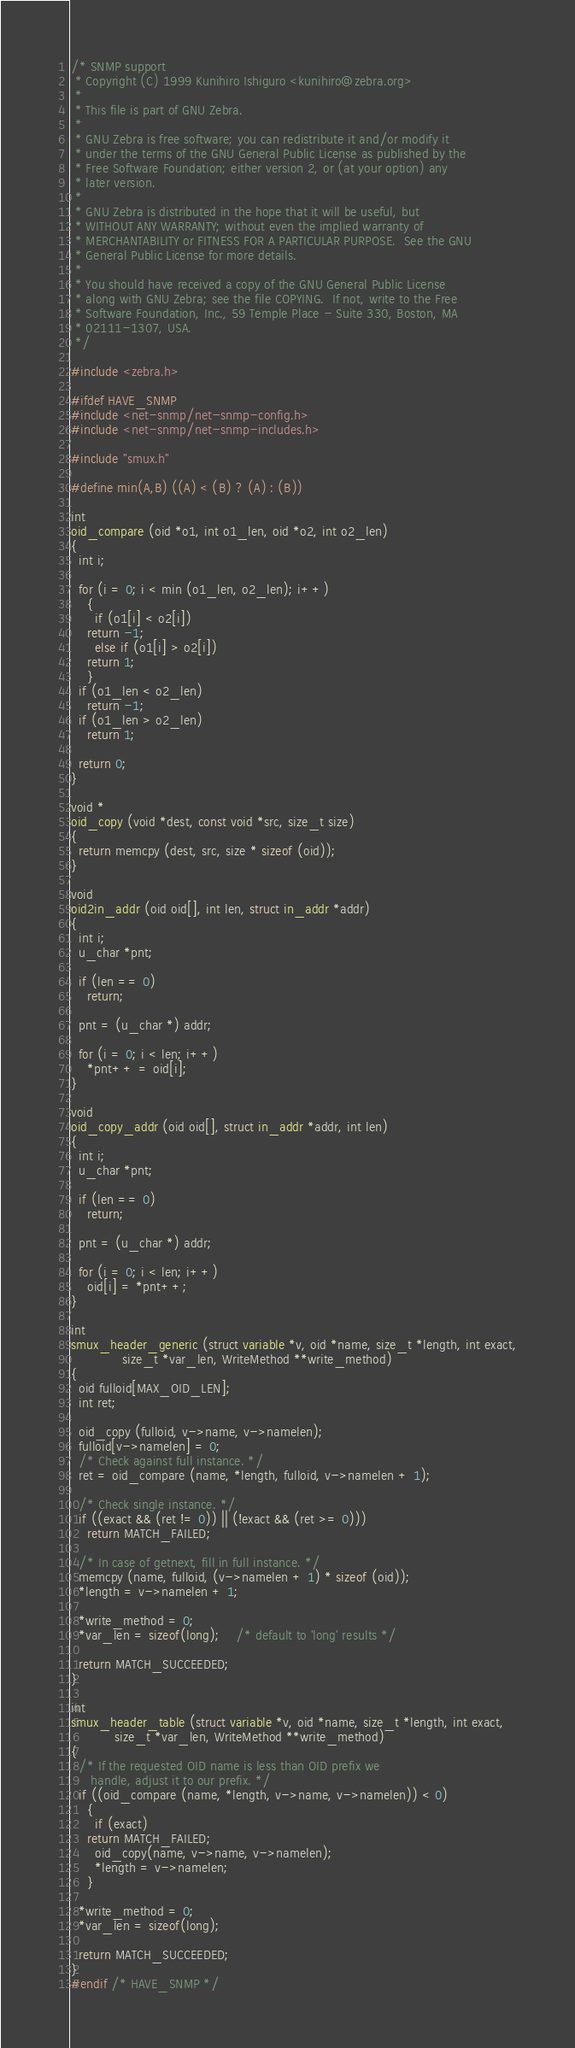<code> <loc_0><loc_0><loc_500><loc_500><_C_>/* SNMP support
 * Copyright (C) 1999 Kunihiro Ishiguro <kunihiro@zebra.org>
 *
 * This file is part of GNU Zebra.
 *
 * GNU Zebra is free software; you can redistribute it and/or modify it
 * under the terms of the GNU General Public License as published by the
 * Free Software Foundation; either version 2, or (at your option) any
 * later version.
 *
 * GNU Zebra is distributed in the hope that it will be useful, but
 * WITHOUT ANY WARRANTY; without even the implied warranty of
 * MERCHANTABILITY or FITNESS FOR A PARTICULAR PURPOSE.  See the GNU
 * General Public License for more details.
 *
 * You should have received a copy of the GNU General Public License
 * along with GNU Zebra; see the file COPYING.  If not, write to the Free
 * Software Foundation, Inc., 59 Temple Place - Suite 330, Boston, MA
 * 02111-1307, USA.  
 */

#include <zebra.h>

#ifdef HAVE_SNMP
#include <net-snmp/net-snmp-config.h>
#include <net-snmp/net-snmp-includes.h>

#include "smux.h"

#define min(A,B) ((A) < (B) ? (A) : (B))

int
oid_compare (oid *o1, int o1_len, oid *o2, int o2_len)
{
  int i;

  for (i = 0; i < min (o1_len, o2_len); i++)
    {
      if (o1[i] < o2[i])
	return -1;
      else if (o1[i] > o2[i])
	return 1;
    }
  if (o1_len < o2_len)
    return -1;
  if (o1_len > o2_len)
    return 1;

  return 0;
}

void *
oid_copy (void *dest, const void *src, size_t size)
{
  return memcpy (dest, src, size * sizeof (oid));
}

void
oid2in_addr (oid oid[], int len, struct in_addr *addr)
{
  int i;
  u_char *pnt;
  
  if (len == 0)
    return;

  pnt = (u_char *) addr;

  for (i = 0; i < len; i++)
    *pnt++ = oid[i];
}

void
oid_copy_addr (oid oid[], struct in_addr *addr, int len)
{
  int i;
  u_char *pnt;
  
  if (len == 0)
    return;

  pnt = (u_char *) addr;

  for (i = 0; i < len; i++)
    oid[i] = *pnt++;
}

int
smux_header_generic (struct variable *v, oid *name, size_t *length, int exact,
		     size_t *var_len, WriteMethod **write_method)
{
  oid fulloid[MAX_OID_LEN];
  int ret;

  oid_copy (fulloid, v->name, v->namelen);
  fulloid[v->namelen] = 0;
  /* Check against full instance. */
  ret = oid_compare (name, *length, fulloid, v->namelen + 1);

  /* Check single instance. */
  if ((exact && (ret != 0)) || (!exact && (ret >= 0)))
	return MATCH_FAILED;

  /* In case of getnext, fill in full instance. */
  memcpy (name, fulloid, (v->namelen + 1) * sizeof (oid));
  *length = v->namelen + 1;

  *write_method = 0;
  *var_len = sizeof(long);    /* default to 'long' results */

  return MATCH_SUCCEEDED;
}

int
smux_header_table (struct variable *v, oid *name, size_t *length, int exact,
		   size_t *var_len, WriteMethod **write_method)
{
  /* If the requested OID name is less than OID prefix we
     handle, adjust it to our prefix. */
  if ((oid_compare (name, *length, v->name, v->namelen)) < 0)
    {
      if (exact)
	return MATCH_FAILED;
      oid_copy(name, v->name, v->namelen);
      *length = v->namelen;
    }

  *write_method = 0;
  *var_len = sizeof(long);

  return MATCH_SUCCEEDED;
}
#endif /* HAVE_SNMP */
</code> 